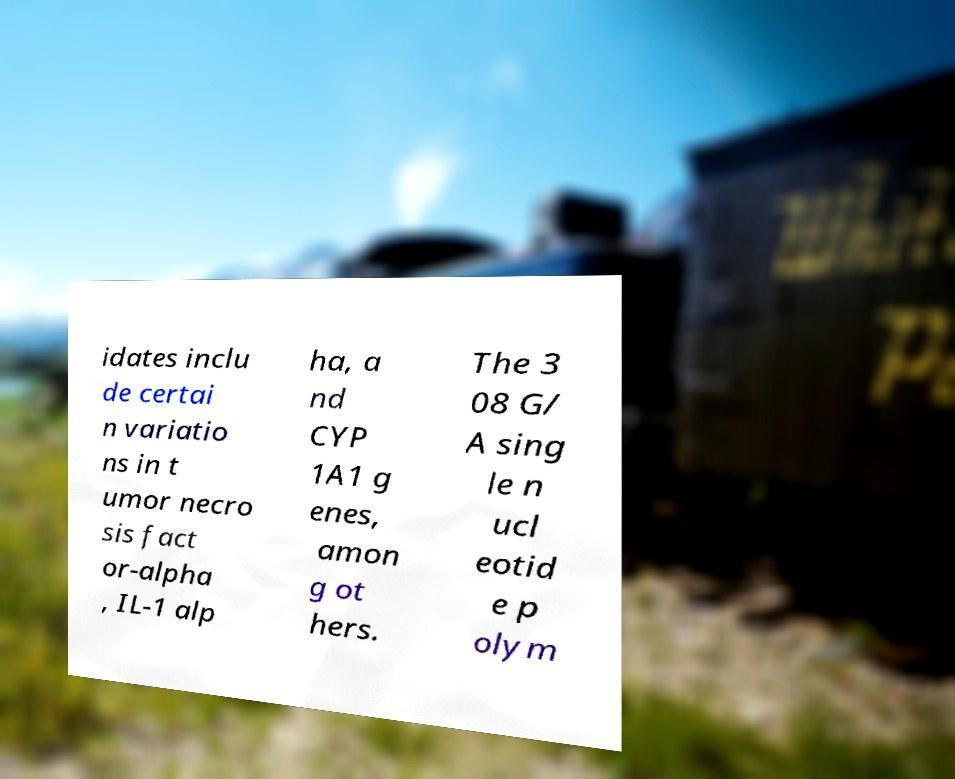Can you accurately transcribe the text from the provided image for me? idates inclu de certai n variatio ns in t umor necro sis fact or-alpha , IL-1 alp ha, a nd CYP 1A1 g enes, amon g ot hers. The 3 08 G/ A sing le n ucl eotid e p olym 